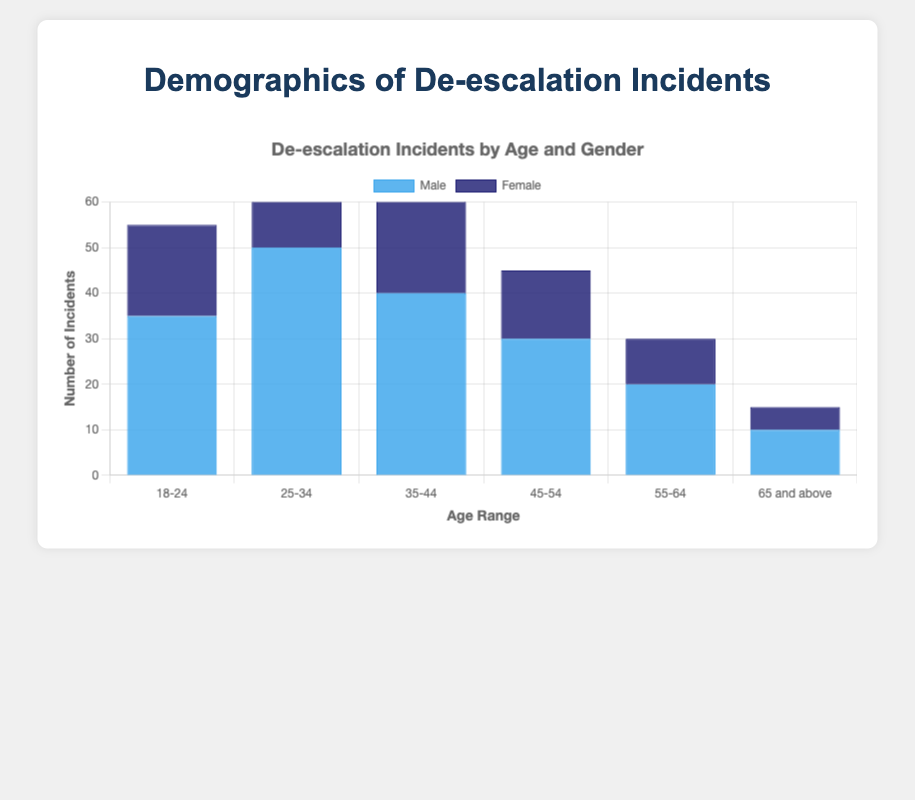How many incidents are recorded for males aged 25-34 and females aged 18-24 combined? For males aged 25-34, there are 50 incidents. For females aged 18-24, there are 20 incidents. Adding these together, 50 + 20 = 70 incidents.
Answer: 70 Which age group has the highest number of de-escalation incidents for males? The age group 25-34 has the highest number of incidents for males, with 50 incidents.
Answer: 25-34 What is the difference in the number of incidents between females aged 35-44 and males aged 55-64? For females aged 35-44, there are 25 incidents. For males aged 55-64, there are 20 incidents. The difference is 25 - 20 = 5 incidents.
Answer: 5 Which gender has fewer incidents in the 45-54 age range? Females in the 45-54 age range have 15 incidents, while males have 30. Therefore, females have fewer incidents.
Answer: Females Does the height of the bars for males generally decrease, stay the same, or increase as age increases? The height of the bars for males generally decreases as age increases, starting from 35 for ages 18-24 and decreasing to 10 for 65 and above.
Answer: Decrease Summing the incidents across all age groups, what is the total number of incidents for females? Summing the incidents for females: 20 (18-24) + 30 (25-34) + 25 (35-44) + 15 (45-54) + 10 (55-64) + 5 (65 and above) = 105 total incidents.
Answer: 105 In which age range is the difference between male and female incidents the greatest? For age range 25-34, males have 50 incidents and females have 30, the difference is 50 - 30 = 20 incidents. This is the greatest difference.
Answer: 25-34 Which age group has the least number of incidents overall (combining both genders)? The 65 and above age group has a total of 15 incidents (10 male and 5 female), which is the least overall.
Answer: 65 and above 